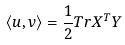<formula> <loc_0><loc_0><loc_500><loc_500>\langle u , v \rangle = \frac { 1 } { 2 } T r X ^ { T } Y</formula> 